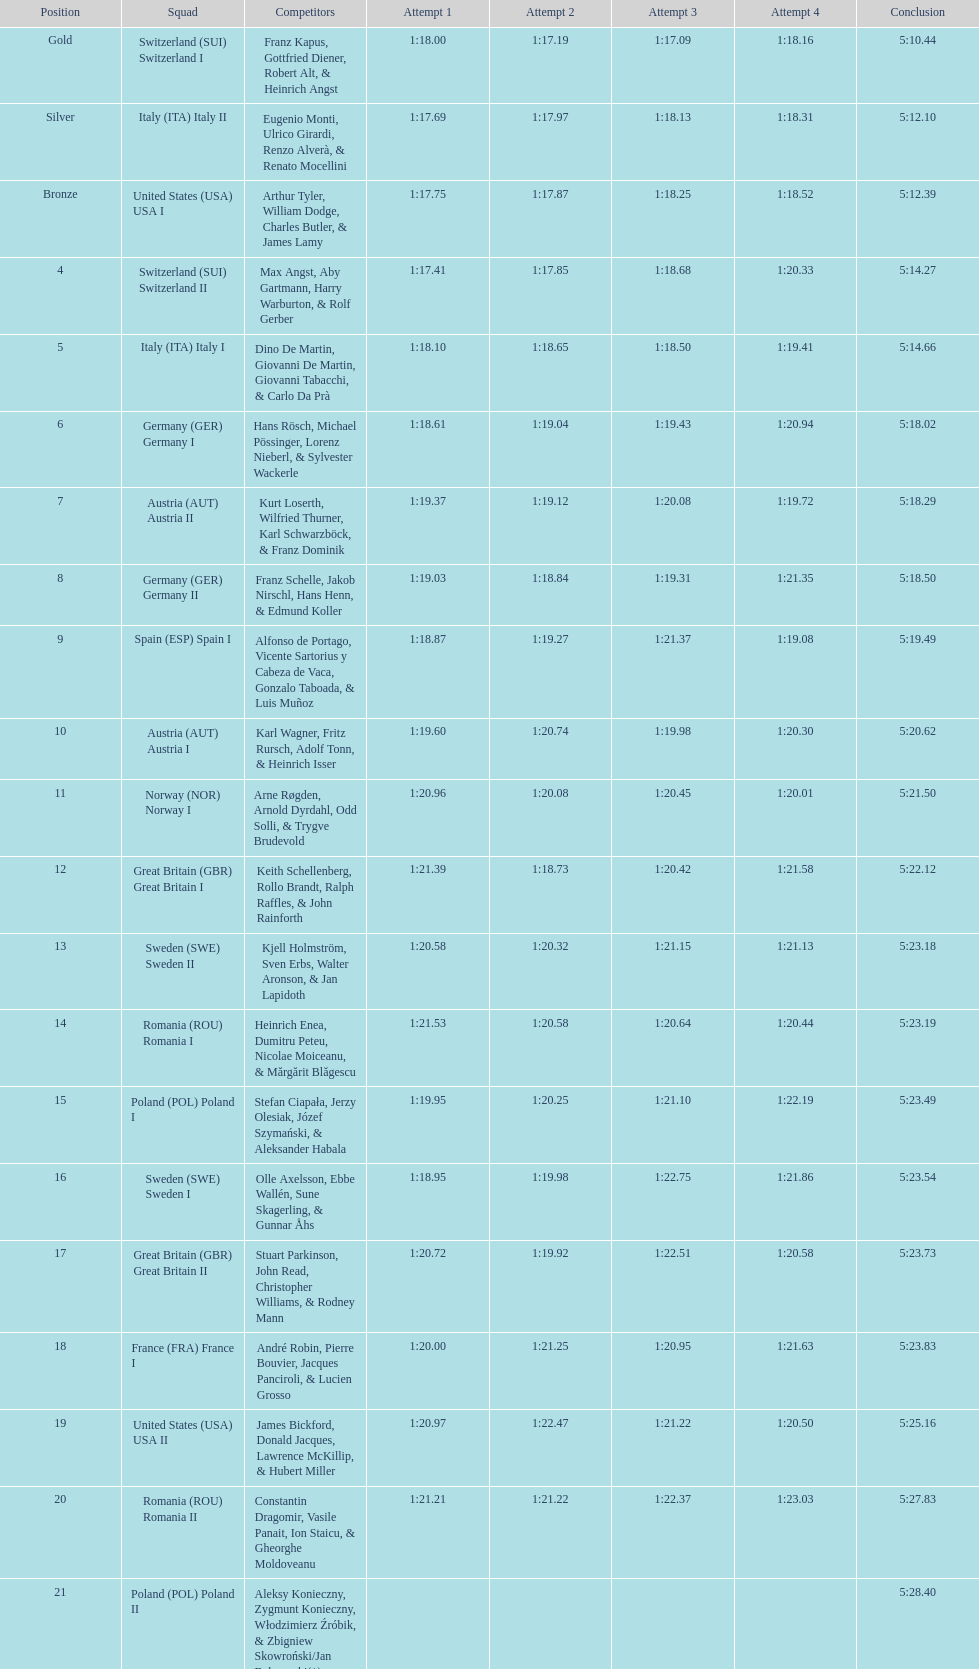What team came out on top? Switzerland. 